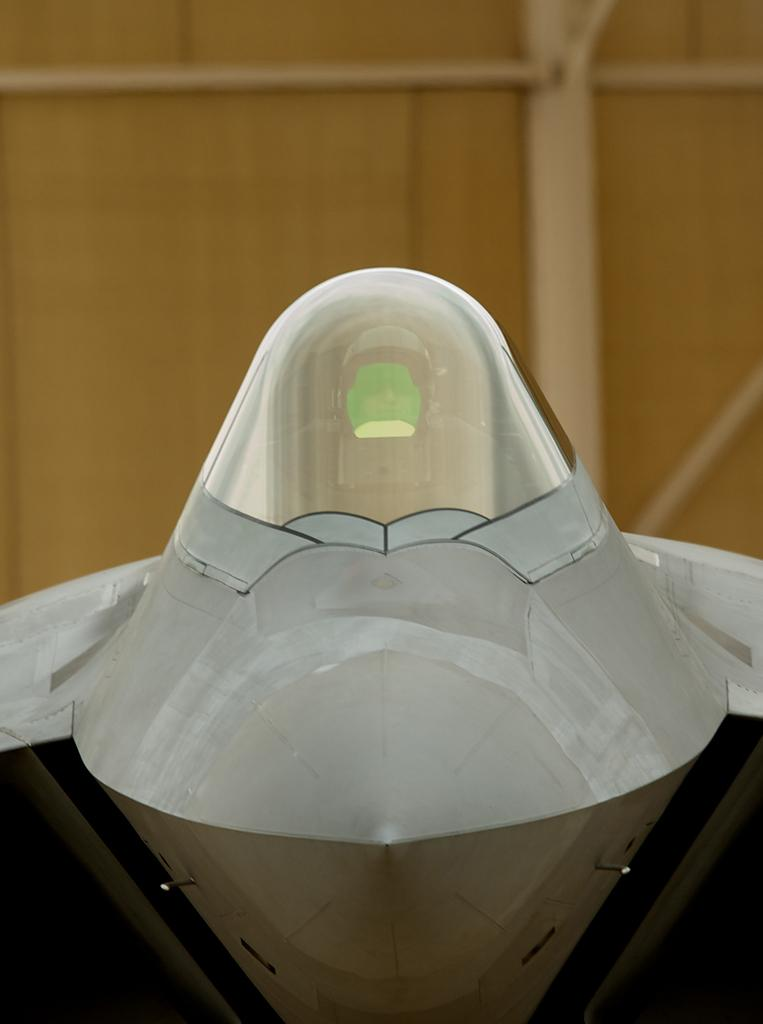What is the main subject of the image? The main subject of the image is a model of an aircraft. What type of material is used for the wall in the image? The wall in the image is made of wood. What things can be seen smashing into the wooden wall in the image? There is no indication of any objects smashing into the wooden wall in the image. How many sticks are attached to the wooden wall in the image? There is no mention of any sticks attached to the wooden wall in the image. 